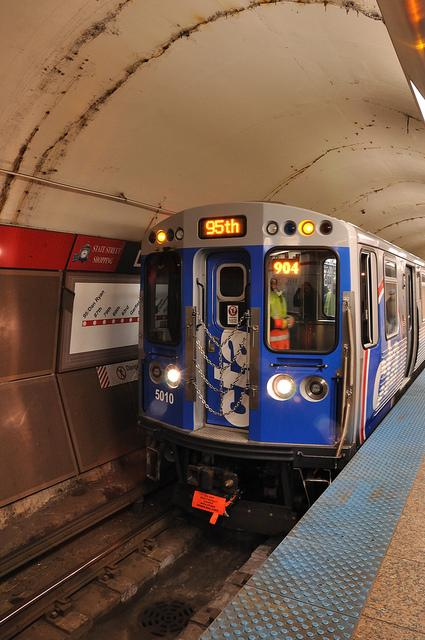In what US city is this subway station located in?

Choices:
A) los angeles
B) chicago
C) new york
D) seattle chicago 